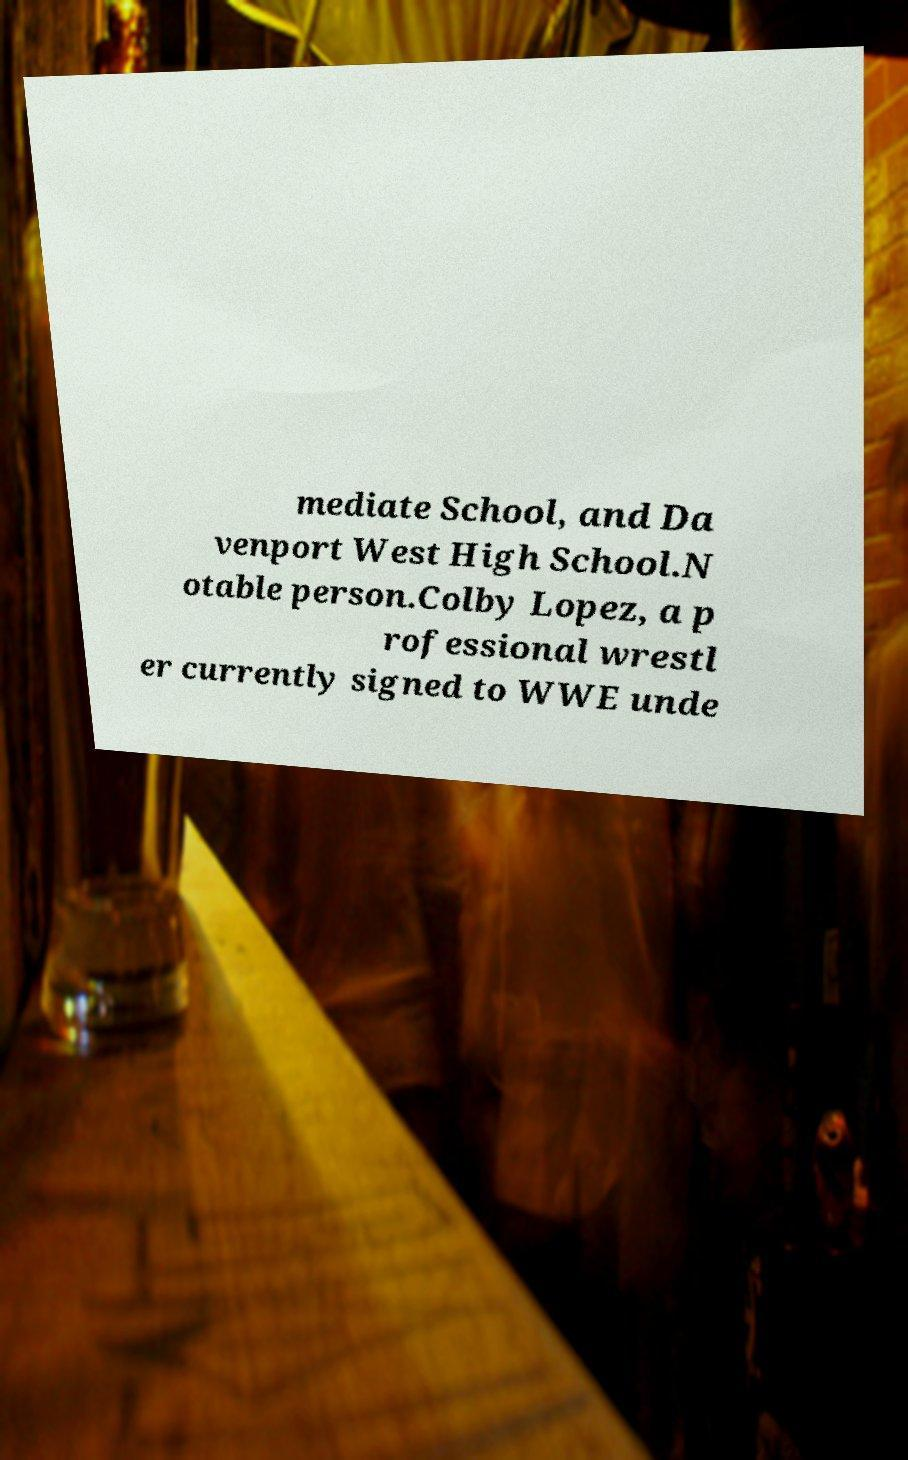Could you extract and type out the text from this image? mediate School, and Da venport West High School.N otable person.Colby Lopez, a p rofessional wrestl er currently signed to WWE unde 